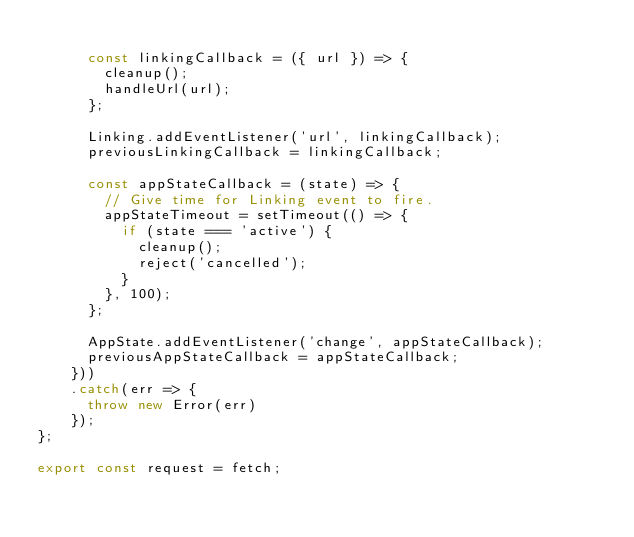<code> <loc_0><loc_0><loc_500><loc_500><_JavaScript_>
      const linkingCallback = ({ url }) => {
        cleanup();
        handleUrl(url);
      };

      Linking.addEventListener('url', linkingCallback);
      previousLinkingCallback = linkingCallback;

      const appStateCallback = (state) => {
        // Give time for Linking event to fire.
        appStateTimeout = setTimeout(() => {
          if (state === 'active') {
            cleanup();
            reject('cancelled');
          }
        }, 100);
      };

      AppState.addEventListener('change', appStateCallback);
      previousAppStateCallback = appStateCallback;
    }))
    .catch(err => {
      throw new Error(err)
    });
};

export const request = fetch;
</code> 